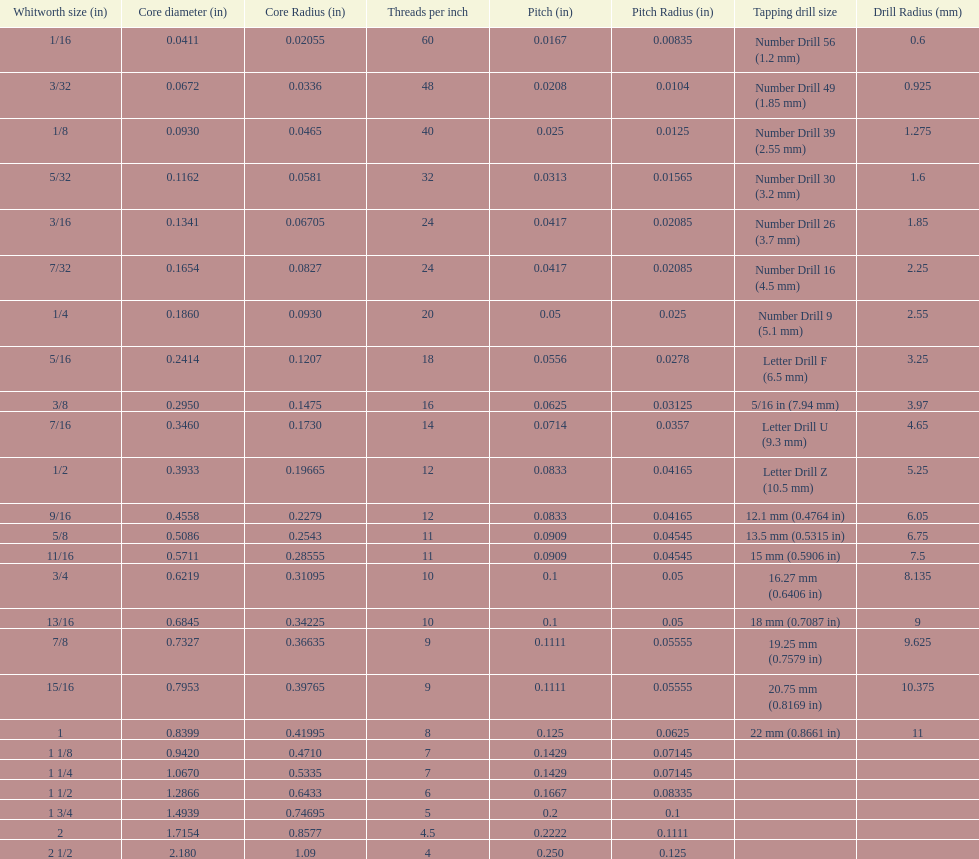Which whitworth size has the same number of threads per inch as 3/16? 7/32. 